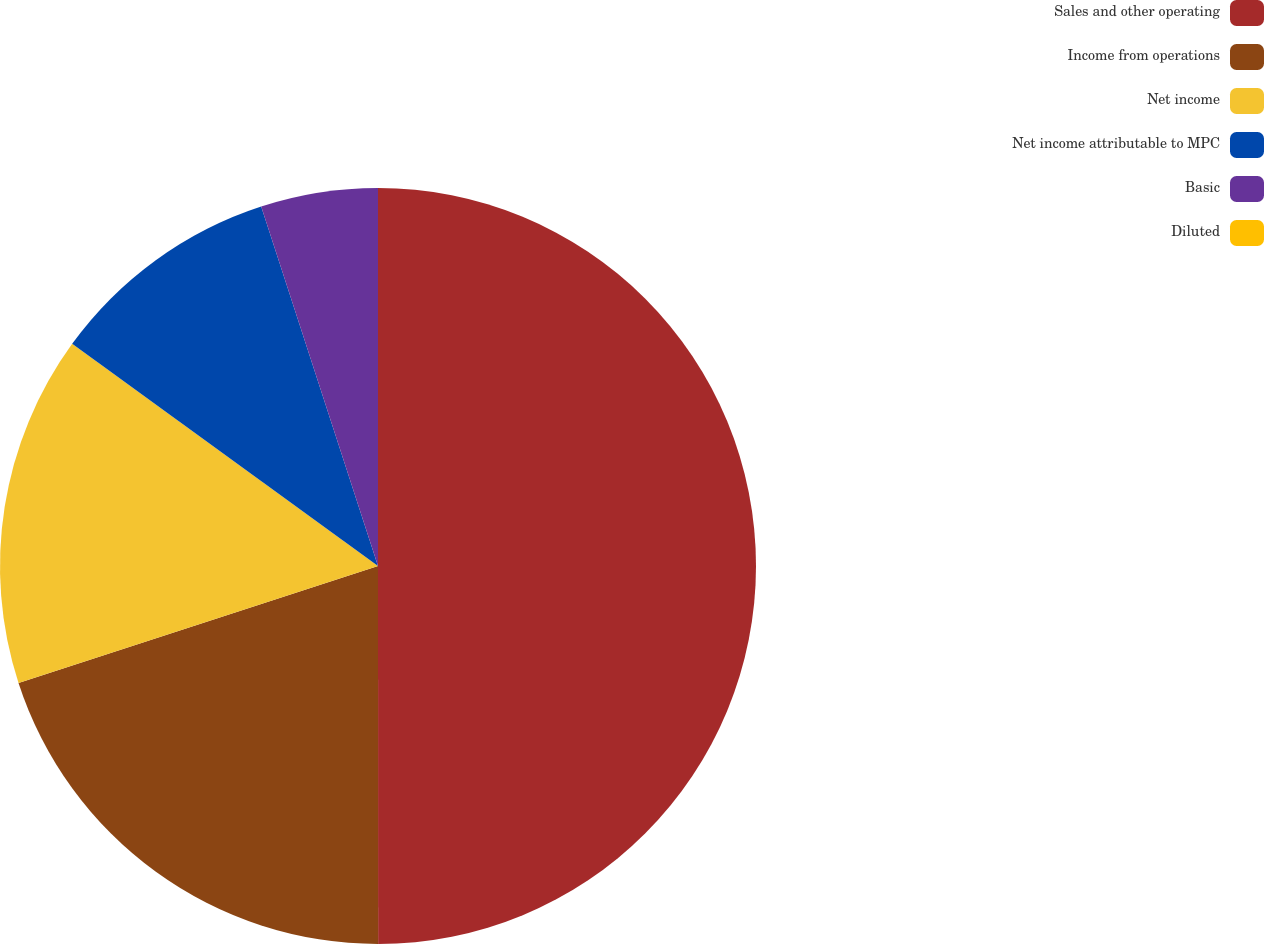<chart> <loc_0><loc_0><loc_500><loc_500><pie_chart><fcel>Sales and other operating<fcel>Income from operations<fcel>Net income<fcel>Net income attributable to MPC<fcel>Basic<fcel>Diluted<nl><fcel>49.99%<fcel>20.0%<fcel>15.0%<fcel>10.0%<fcel>5.0%<fcel>0.0%<nl></chart> 